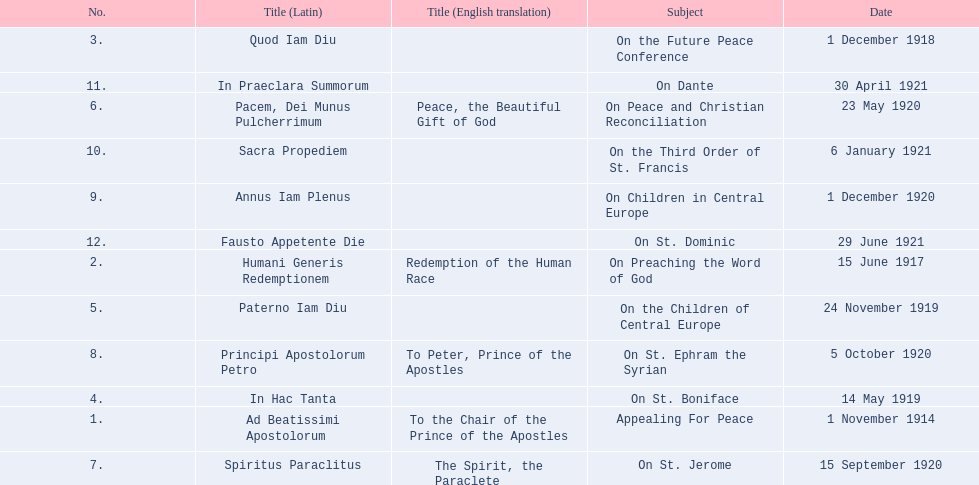What is the first english translation listed on the table? To the Chair of the Prince of the Apostles. 